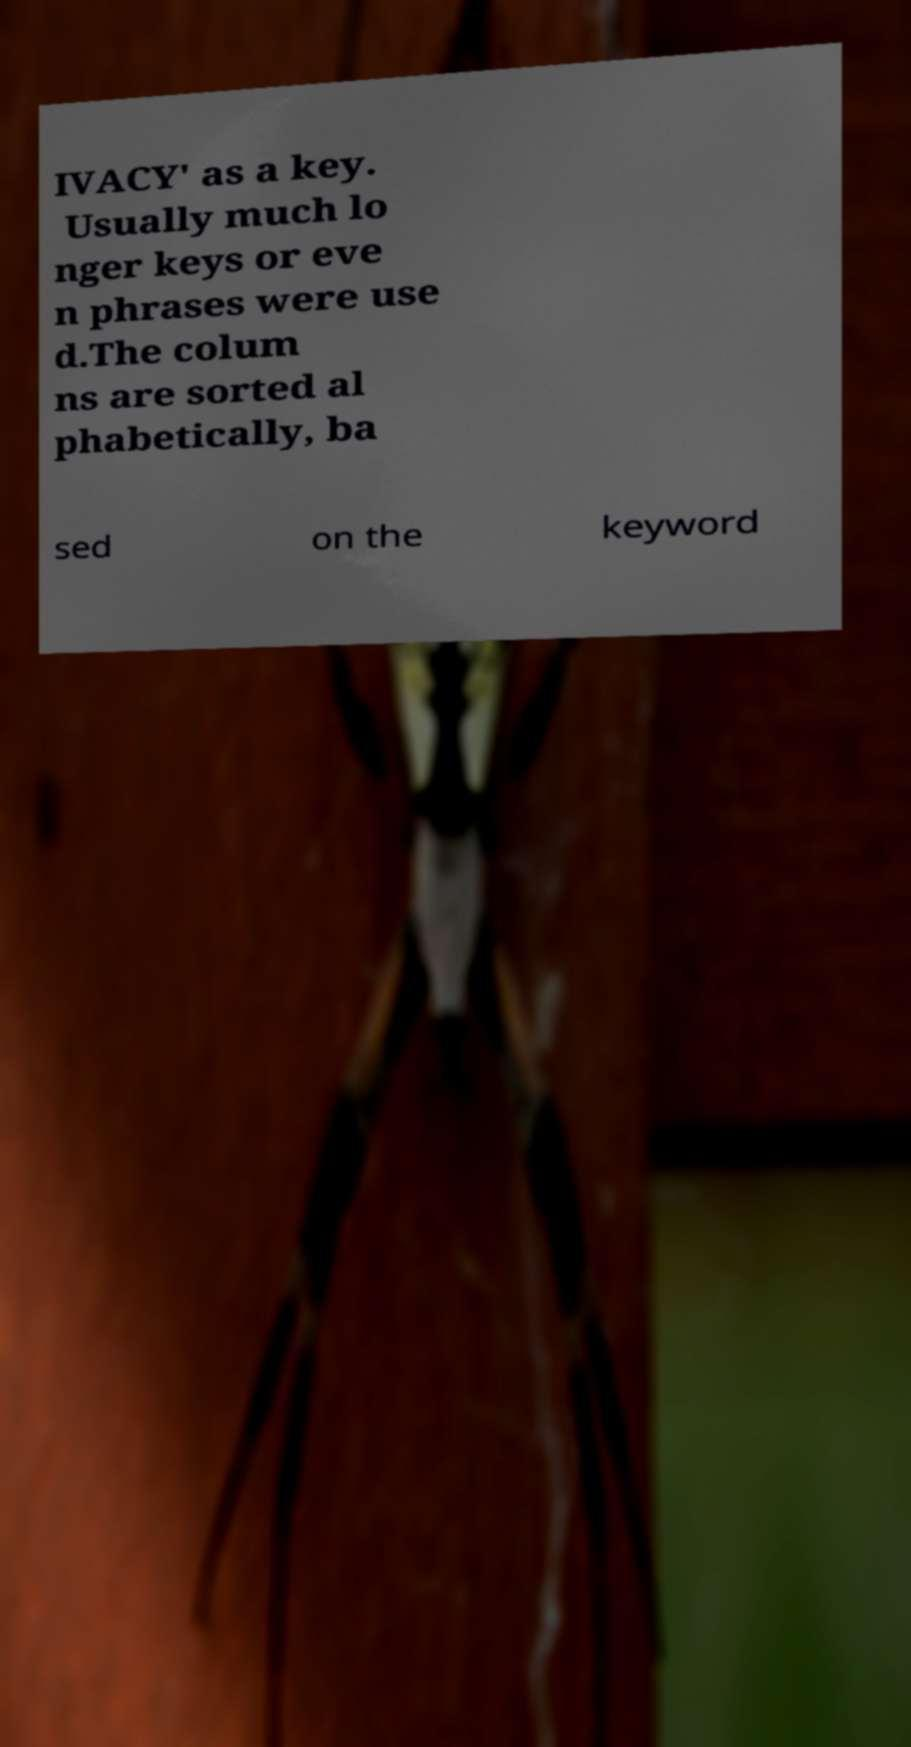I need the written content from this picture converted into text. Can you do that? IVACY' as a key. Usually much lo nger keys or eve n phrases were use d.The colum ns are sorted al phabetically, ba sed on the keyword 